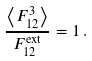Convert formula to latex. <formula><loc_0><loc_0><loc_500><loc_500>\frac { \left \langle F ^ { 3 } _ { 1 2 } \right \rangle } { F ^ { \text {ext} } _ { 1 2 } } = 1 \, .</formula> 